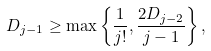Convert formula to latex. <formula><loc_0><loc_0><loc_500><loc_500>D _ { j - 1 } \geq \max \left \{ \frac { 1 } { j ! } , \frac { 2 D _ { j - 2 } } { j - 1 } \right \} ,</formula> 